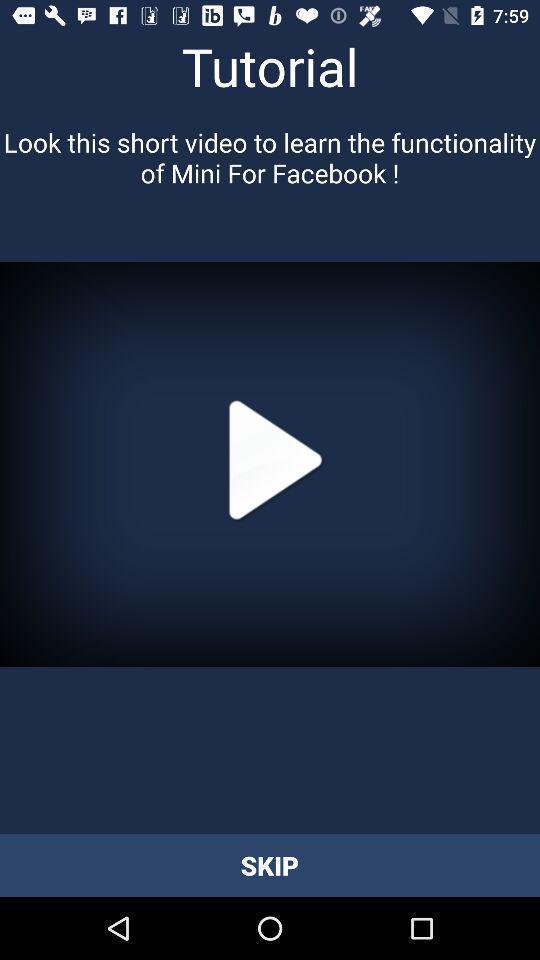What is the overall content of this screenshot? Page showing video in learning app. 